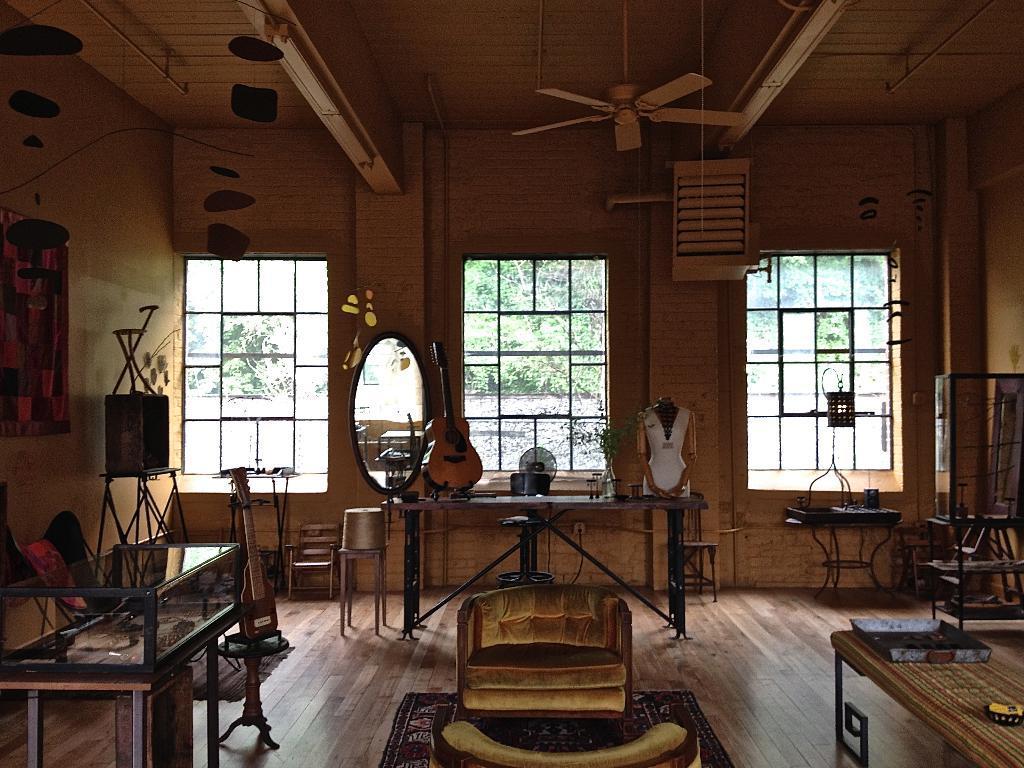Could you give a brief overview of what you see in this image? This image is taken indoors. At the bottom of the image there is a floor. In the background there is a wall with a picture frame, windows and a lamp. On the left side of the image there is a table with a few things on it and there are a few musical instruments on the floor. In the middle of the image there is a couch and a table with a few things on it. There is a mirror on the wall. On the right side of the image there is a table. 